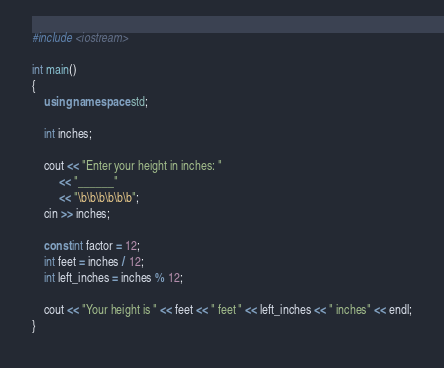<code> <loc_0><loc_0><loc_500><loc_500><_C++_>#include <iostream>

int main()
{
    using namespace std;

    int inches;

    cout << "Enter your height in inches: "
         << "______"
         << "\b\b\b\b\b\b";
    cin >> inches;

    const int factor = 12;
    int feet = inches / 12;
    int left_inches = inches % 12;

    cout << "Your height is " << feet << " feet " << left_inches << " inches" << endl;
}</code> 